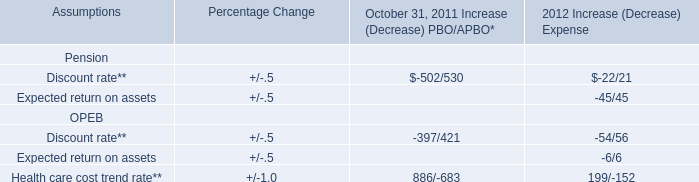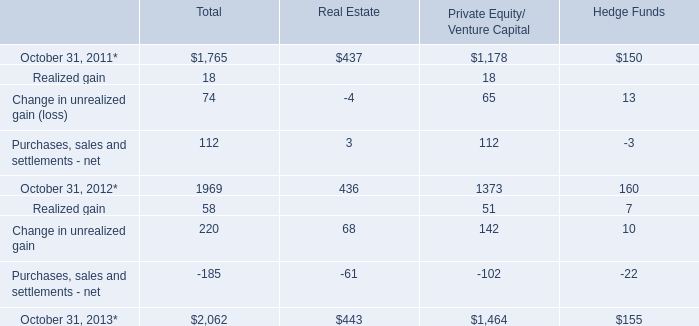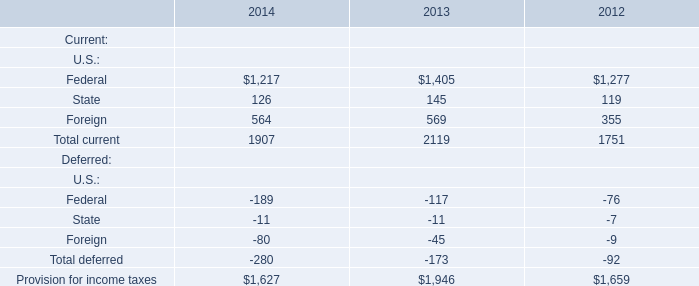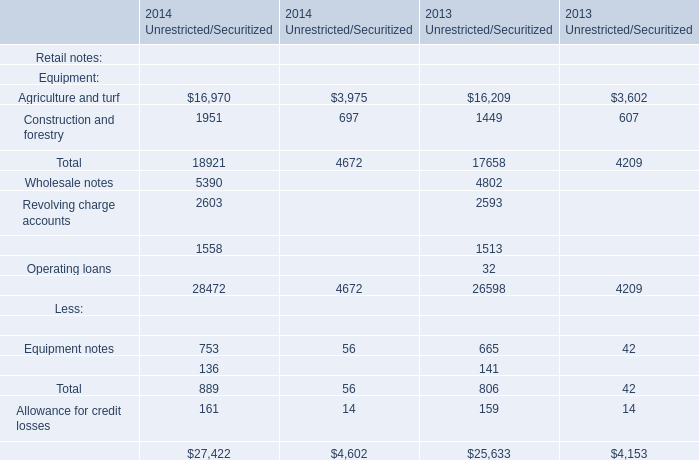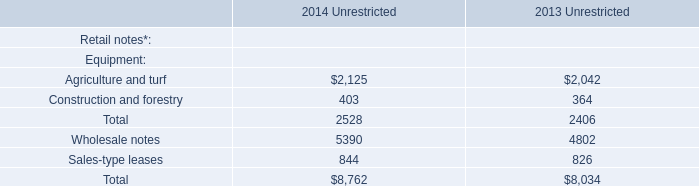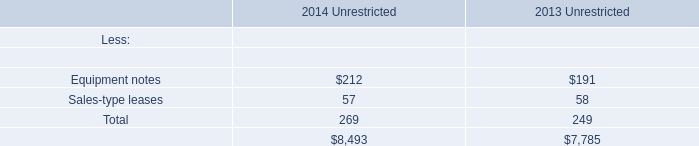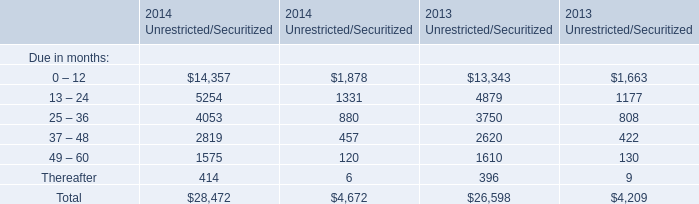What's the average of Due in months(1-12) in Unrestricted in 2014 and 2013? 
Computations: ((14357 + 13343) / 2)
Answer: 13850.0. 